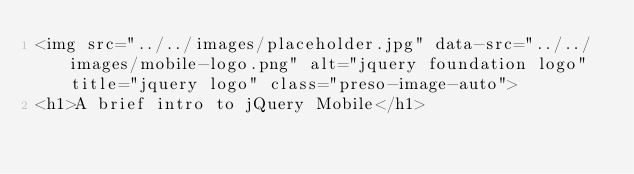<code> <loc_0><loc_0><loc_500><loc_500><_HTML_><img src="../../images/placeholder.jpg" data-src="../../images/mobile-logo.png" alt="jquery foundation logo" title="jquery logo" class="preso-image-auto">
<h1>A brief intro to jQuery Mobile</h1></code> 